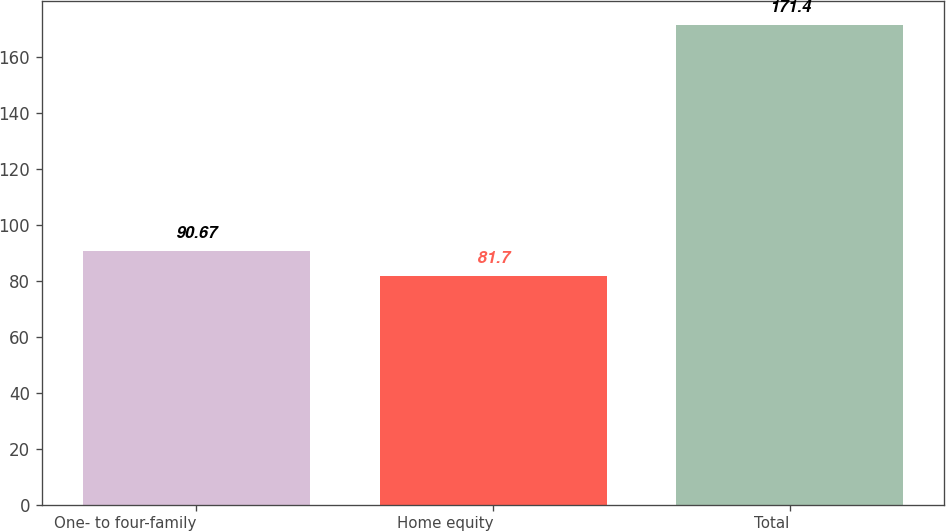Convert chart to OTSL. <chart><loc_0><loc_0><loc_500><loc_500><bar_chart><fcel>One- to four-family<fcel>Home equity<fcel>Total<nl><fcel>90.67<fcel>81.7<fcel>171.4<nl></chart> 